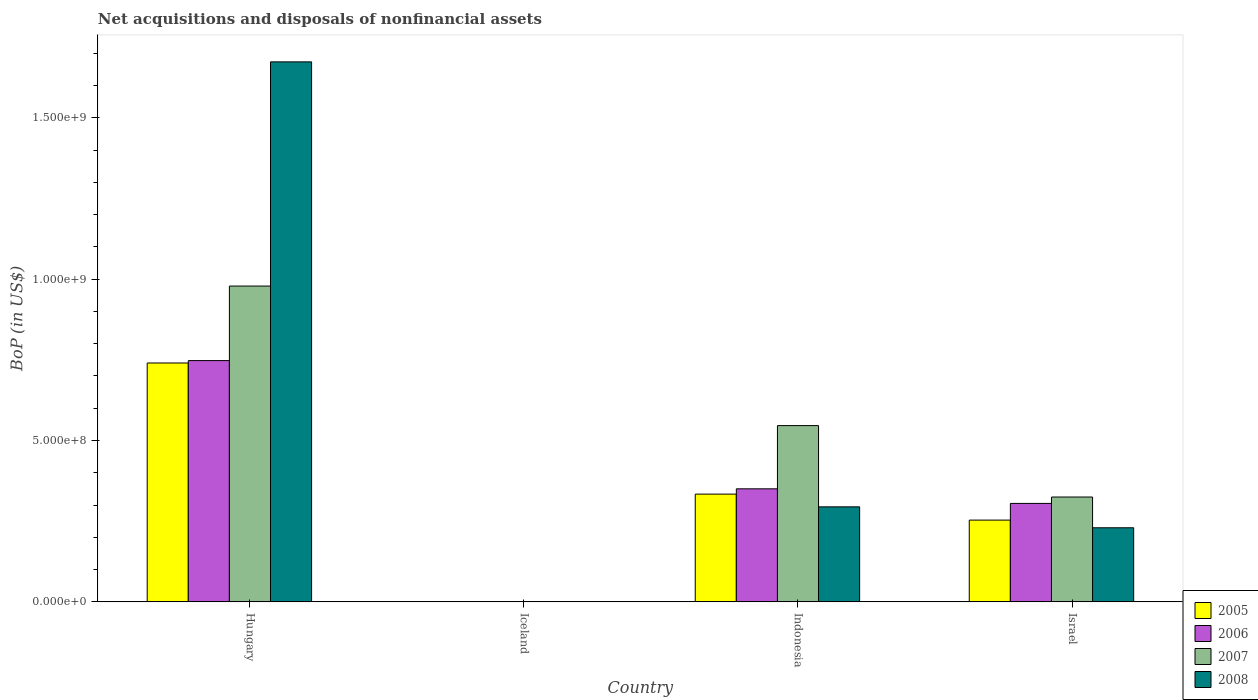How many different coloured bars are there?
Keep it short and to the point. 4. Are the number of bars per tick equal to the number of legend labels?
Ensure brevity in your answer.  No. How many bars are there on the 1st tick from the right?
Make the answer very short. 4. What is the label of the 1st group of bars from the left?
Ensure brevity in your answer.  Hungary. In how many cases, is the number of bars for a given country not equal to the number of legend labels?
Offer a very short reply. 1. What is the Balance of Payments in 2008 in Indonesia?
Provide a succinct answer. 2.94e+08. Across all countries, what is the maximum Balance of Payments in 2008?
Keep it short and to the point. 1.67e+09. In which country was the Balance of Payments in 2008 maximum?
Provide a succinct answer. Hungary. What is the total Balance of Payments in 2007 in the graph?
Give a very brief answer. 1.85e+09. What is the difference between the Balance of Payments in 2006 in Hungary and that in Indonesia?
Offer a very short reply. 3.97e+08. What is the difference between the Balance of Payments in 2007 in Indonesia and the Balance of Payments in 2005 in Hungary?
Your answer should be compact. -1.94e+08. What is the average Balance of Payments in 2007 per country?
Keep it short and to the point. 4.62e+08. What is the difference between the Balance of Payments of/in 2008 and Balance of Payments of/in 2005 in Indonesia?
Your answer should be very brief. -3.95e+07. What is the ratio of the Balance of Payments in 2007 in Hungary to that in Indonesia?
Your response must be concise. 1.79. Is the Balance of Payments in 2006 in Indonesia less than that in Israel?
Your response must be concise. No. Is the difference between the Balance of Payments in 2008 in Hungary and Israel greater than the difference between the Balance of Payments in 2005 in Hungary and Israel?
Give a very brief answer. Yes. What is the difference between the highest and the second highest Balance of Payments in 2005?
Make the answer very short. -4.87e+08. What is the difference between the highest and the lowest Balance of Payments in 2008?
Provide a succinct answer. 1.67e+09. Is it the case that in every country, the sum of the Balance of Payments in 2008 and Balance of Payments in 2005 is greater than the sum of Balance of Payments in 2007 and Balance of Payments in 2006?
Your answer should be very brief. No. How many bars are there?
Make the answer very short. 12. Are all the bars in the graph horizontal?
Your response must be concise. No. What is the difference between two consecutive major ticks on the Y-axis?
Your answer should be compact. 5.00e+08. Does the graph contain any zero values?
Keep it short and to the point. Yes. Where does the legend appear in the graph?
Make the answer very short. Bottom right. How are the legend labels stacked?
Provide a succinct answer. Vertical. What is the title of the graph?
Your answer should be very brief. Net acquisitions and disposals of nonfinancial assets. Does "2010" appear as one of the legend labels in the graph?
Give a very brief answer. No. What is the label or title of the Y-axis?
Your answer should be very brief. BoP (in US$). What is the BoP (in US$) in 2005 in Hungary?
Provide a succinct answer. 7.40e+08. What is the BoP (in US$) of 2006 in Hungary?
Keep it short and to the point. 7.48e+08. What is the BoP (in US$) of 2007 in Hungary?
Provide a succinct answer. 9.79e+08. What is the BoP (in US$) in 2008 in Hungary?
Your response must be concise. 1.67e+09. What is the BoP (in US$) in 2008 in Iceland?
Give a very brief answer. 0. What is the BoP (in US$) of 2005 in Indonesia?
Your response must be concise. 3.34e+08. What is the BoP (in US$) in 2006 in Indonesia?
Provide a succinct answer. 3.50e+08. What is the BoP (in US$) in 2007 in Indonesia?
Provide a short and direct response. 5.46e+08. What is the BoP (in US$) of 2008 in Indonesia?
Your answer should be compact. 2.94e+08. What is the BoP (in US$) in 2005 in Israel?
Your answer should be compact. 2.53e+08. What is the BoP (in US$) of 2006 in Israel?
Ensure brevity in your answer.  3.05e+08. What is the BoP (in US$) of 2007 in Israel?
Keep it short and to the point. 3.25e+08. What is the BoP (in US$) of 2008 in Israel?
Offer a terse response. 2.30e+08. Across all countries, what is the maximum BoP (in US$) in 2005?
Offer a terse response. 7.40e+08. Across all countries, what is the maximum BoP (in US$) of 2006?
Your answer should be compact. 7.48e+08. Across all countries, what is the maximum BoP (in US$) in 2007?
Your answer should be compact. 9.79e+08. Across all countries, what is the maximum BoP (in US$) in 2008?
Provide a short and direct response. 1.67e+09. Across all countries, what is the minimum BoP (in US$) in 2005?
Your answer should be very brief. 0. Across all countries, what is the minimum BoP (in US$) in 2006?
Offer a terse response. 0. Across all countries, what is the minimum BoP (in US$) of 2007?
Your answer should be compact. 0. What is the total BoP (in US$) of 2005 in the graph?
Offer a terse response. 1.33e+09. What is the total BoP (in US$) in 2006 in the graph?
Your answer should be compact. 1.40e+09. What is the total BoP (in US$) in 2007 in the graph?
Your answer should be very brief. 1.85e+09. What is the total BoP (in US$) of 2008 in the graph?
Offer a terse response. 2.20e+09. What is the difference between the BoP (in US$) of 2005 in Hungary and that in Indonesia?
Offer a very short reply. 4.06e+08. What is the difference between the BoP (in US$) in 2006 in Hungary and that in Indonesia?
Make the answer very short. 3.97e+08. What is the difference between the BoP (in US$) of 2007 in Hungary and that in Indonesia?
Ensure brevity in your answer.  4.32e+08. What is the difference between the BoP (in US$) of 2008 in Hungary and that in Indonesia?
Keep it short and to the point. 1.38e+09. What is the difference between the BoP (in US$) of 2005 in Hungary and that in Israel?
Ensure brevity in your answer.  4.87e+08. What is the difference between the BoP (in US$) in 2006 in Hungary and that in Israel?
Offer a very short reply. 4.43e+08. What is the difference between the BoP (in US$) in 2007 in Hungary and that in Israel?
Offer a very short reply. 6.54e+08. What is the difference between the BoP (in US$) of 2008 in Hungary and that in Israel?
Ensure brevity in your answer.  1.44e+09. What is the difference between the BoP (in US$) in 2005 in Indonesia and that in Israel?
Offer a very short reply. 8.05e+07. What is the difference between the BoP (in US$) of 2006 in Indonesia and that in Israel?
Give a very brief answer. 4.52e+07. What is the difference between the BoP (in US$) in 2007 in Indonesia and that in Israel?
Ensure brevity in your answer.  2.21e+08. What is the difference between the BoP (in US$) of 2008 in Indonesia and that in Israel?
Provide a succinct answer. 6.49e+07. What is the difference between the BoP (in US$) in 2005 in Hungary and the BoP (in US$) in 2006 in Indonesia?
Ensure brevity in your answer.  3.90e+08. What is the difference between the BoP (in US$) of 2005 in Hungary and the BoP (in US$) of 2007 in Indonesia?
Keep it short and to the point. 1.94e+08. What is the difference between the BoP (in US$) of 2005 in Hungary and the BoP (in US$) of 2008 in Indonesia?
Keep it short and to the point. 4.46e+08. What is the difference between the BoP (in US$) of 2006 in Hungary and the BoP (in US$) of 2007 in Indonesia?
Make the answer very short. 2.01e+08. What is the difference between the BoP (in US$) of 2006 in Hungary and the BoP (in US$) of 2008 in Indonesia?
Your answer should be very brief. 4.53e+08. What is the difference between the BoP (in US$) in 2007 in Hungary and the BoP (in US$) in 2008 in Indonesia?
Your response must be concise. 6.84e+08. What is the difference between the BoP (in US$) of 2005 in Hungary and the BoP (in US$) of 2006 in Israel?
Keep it short and to the point. 4.35e+08. What is the difference between the BoP (in US$) in 2005 in Hungary and the BoP (in US$) in 2007 in Israel?
Ensure brevity in your answer.  4.15e+08. What is the difference between the BoP (in US$) of 2005 in Hungary and the BoP (in US$) of 2008 in Israel?
Your answer should be compact. 5.11e+08. What is the difference between the BoP (in US$) of 2006 in Hungary and the BoP (in US$) of 2007 in Israel?
Your answer should be very brief. 4.23e+08. What is the difference between the BoP (in US$) in 2006 in Hungary and the BoP (in US$) in 2008 in Israel?
Provide a succinct answer. 5.18e+08. What is the difference between the BoP (in US$) in 2007 in Hungary and the BoP (in US$) in 2008 in Israel?
Your answer should be compact. 7.49e+08. What is the difference between the BoP (in US$) in 2005 in Indonesia and the BoP (in US$) in 2006 in Israel?
Offer a very short reply. 2.88e+07. What is the difference between the BoP (in US$) in 2005 in Indonesia and the BoP (in US$) in 2007 in Israel?
Give a very brief answer. 9.02e+06. What is the difference between the BoP (in US$) of 2005 in Indonesia and the BoP (in US$) of 2008 in Israel?
Your answer should be compact. 1.04e+08. What is the difference between the BoP (in US$) in 2006 in Indonesia and the BoP (in US$) in 2007 in Israel?
Make the answer very short. 2.54e+07. What is the difference between the BoP (in US$) in 2006 in Indonesia and the BoP (in US$) in 2008 in Israel?
Your answer should be very brief. 1.21e+08. What is the difference between the BoP (in US$) of 2007 in Indonesia and the BoP (in US$) of 2008 in Israel?
Keep it short and to the point. 3.17e+08. What is the average BoP (in US$) of 2005 per country?
Offer a terse response. 3.32e+08. What is the average BoP (in US$) in 2006 per country?
Your answer should be compact. 3.51e+08. What is the average BoP (in US$) in 2007 per country?
Make the answer very short. 4.62e+08. What is the average BoP (in US$) of 2008 per country?
Offer a very short reply. 5.49e+08. What is the difference between the BoP (in US$) of 2005 and BoP (in US$) of 2006 in Hungary?
Provide a short and direct response. -7.44e+06. What is the difference between the BoP (in US$) of 2005 and BoP (in US$) of 2007 in Hungary?
Provide a succinct answer. -2.38e+08. What is the difference between the BoP (in US$) of 2005 and BoP (in US$) of 2008 in Hungary?
Your response must be concise. -9.33e+08. What is the difference between the BoP (in US$) in 2006 and BoP (in US$) in 2007 in Hungary?
Keep it short and to the point. -2.31e+08. What is the difference between the BoP (in US$) of 2006 and BoP (in US$) of 2008 in Hungary?
Provide a short and direct response. -9.26e+08. What is the difference between the BoP (in US$) of 2007 and BoP (in US$) of 2008 in Hungary?
Your answer should be compact. -6.95e+08. What is the difference between the BoP (in US$) in 2005 and BoP (in US$) in 2006 in Indonesia?
Provide a succinct answer. -1.64e+07. What is the difference between the BoP (in US$) in 2005 and BoP (in US$) in 2007 in Indonesia?
Your answer should be compact. -2.12e+08. What is the difference between the BoP (in US$) of 2005 and BoP (in US$) of 2008 in Indonesia?
Provide a succinct answer. 3.95e+07. What is the difference between the BoP (in US$) of 2006 and BoP (in US$) of 2007 in Indonesia?
Your answer should be compact. -1.96e+08. What is the difference between the BoP (in US$) of 2006 and BoP (in US$) of 2008 in Indonesia?
Your answer should be very brief. 5.59e+07. What is the difference between the BoP (in US$) in 2007 and BoP (in US$) in 2008 in Indonesia?
Give a very brief answer. 2.52e+08. What is the difference between the BoP (in US$) of 2005 and BoP (in US$) of 2006 in Israel?
Your answer should be very brief. -5.17e+07. What is the difference between the BoP (in US$) of 2005 and BoP (in US$) of 2007 in Israel?
Your answer should be very brief. -7.15e+07. What is the difference between the BoP (in US$) in 2005 and BoP (in US$) in 2008 in Israel?
Offer a terse response. 2.38e+07. What is the difference between the BoP (in US$) in 2006 and BoP (in US$) in 2007 in Israel?
Offer a very short reply. -1.98e+07. What is the difference between the BoP (in US$) of 2006 and BoP (in US$) of 2008 in Israel?
Offer a terse response. 7.55e+07. What is the difference between the BoP (in US$) in 2007 and BoP (in US$) in 2008 in Israel?
Offer a terse response. 9.53e+07. What is the ratio of the BoP (in US$) in 2005 in Hungary to that in Indonesia?
Ensure brevity in your answer.  2.22. What is the ratio of the BoP (in US$) in 2006 in Hungary to that in Indonesia?
Your response must be concise. 2.13. What is the ratio of the BoP (in US$) in 2007 in Hungary to that in Indonesia?
Offer a terse response. 1.79. What is the ratio of the BoP (in US$) of 2008 in Hungary to that in Indonesia?
Your answer should be very brief. 5.68. What is the ratio of the BoP (in US$) of 2005 in Hungary to that in Israel?
Offer a terse response. 2.92. What is the ratio of the BoP (in US$) of 2006 in Hungary to that in Israel?
Ensure brevity in your answer.  2.45. What is the ratio of the BoP (in US$) of 2007 in Hungary to that in Israel?
Keep it short and to the point. 3.01. What is the ratio of the BoP (in US$) of 2008 in Hungary to that in Israel?
Offer a very short reply. 7.29. What is the ratio of the BoP (in US$) in 2005 in Indonesia to that in Israel?
Make the answer very short. 1.32. What is the ratio of the BoP (in US$) in 2006 in Indonesia to that in Israel?
Keep it short and to the point. 1.15. What is the ratio of the BoP (in US$) of 2007 in Indonesia to that in Israel?
Ensure brevity in your answer.  1.68. What is the ratio of the BoP (in US$) of 2008 in Indonesia to that in Israel?
Ensure brevity in your answer.  1.28. What is the difference between the highest and the second highest BoP (in US$) of 2005?
Make the answer very short. 4.06e+08. What is the difference between the highest and the second highest BoP (in US$) of 2006?
Your answer should be compact. 3.97e+08. What is the difference between the highest and the second highest BoP (in US$) in 2007?
Your answer should be very brief. 4.32e+08. What is the difference between the highest and the second highest BoP (in US$) of 2008?
Offer a terse response. 1.38e+09. What is the difference between the highest and the lowest BoP (in US$) of 2005?
Provide a succinct answer. 7.40e+08. What is the difference between the highest and the lowest BoP (in US$) in 2006?
Your answer should be very brief. 7.48e+08. What is the difference between the highest and the lowest BoP (in US$) of 2007?
Provide a succinct answer. 9.79e+08. What is the difference between the highest and the lowest BoP (in US$) of 2008?
Your response must be concise. 1.67e+09. 